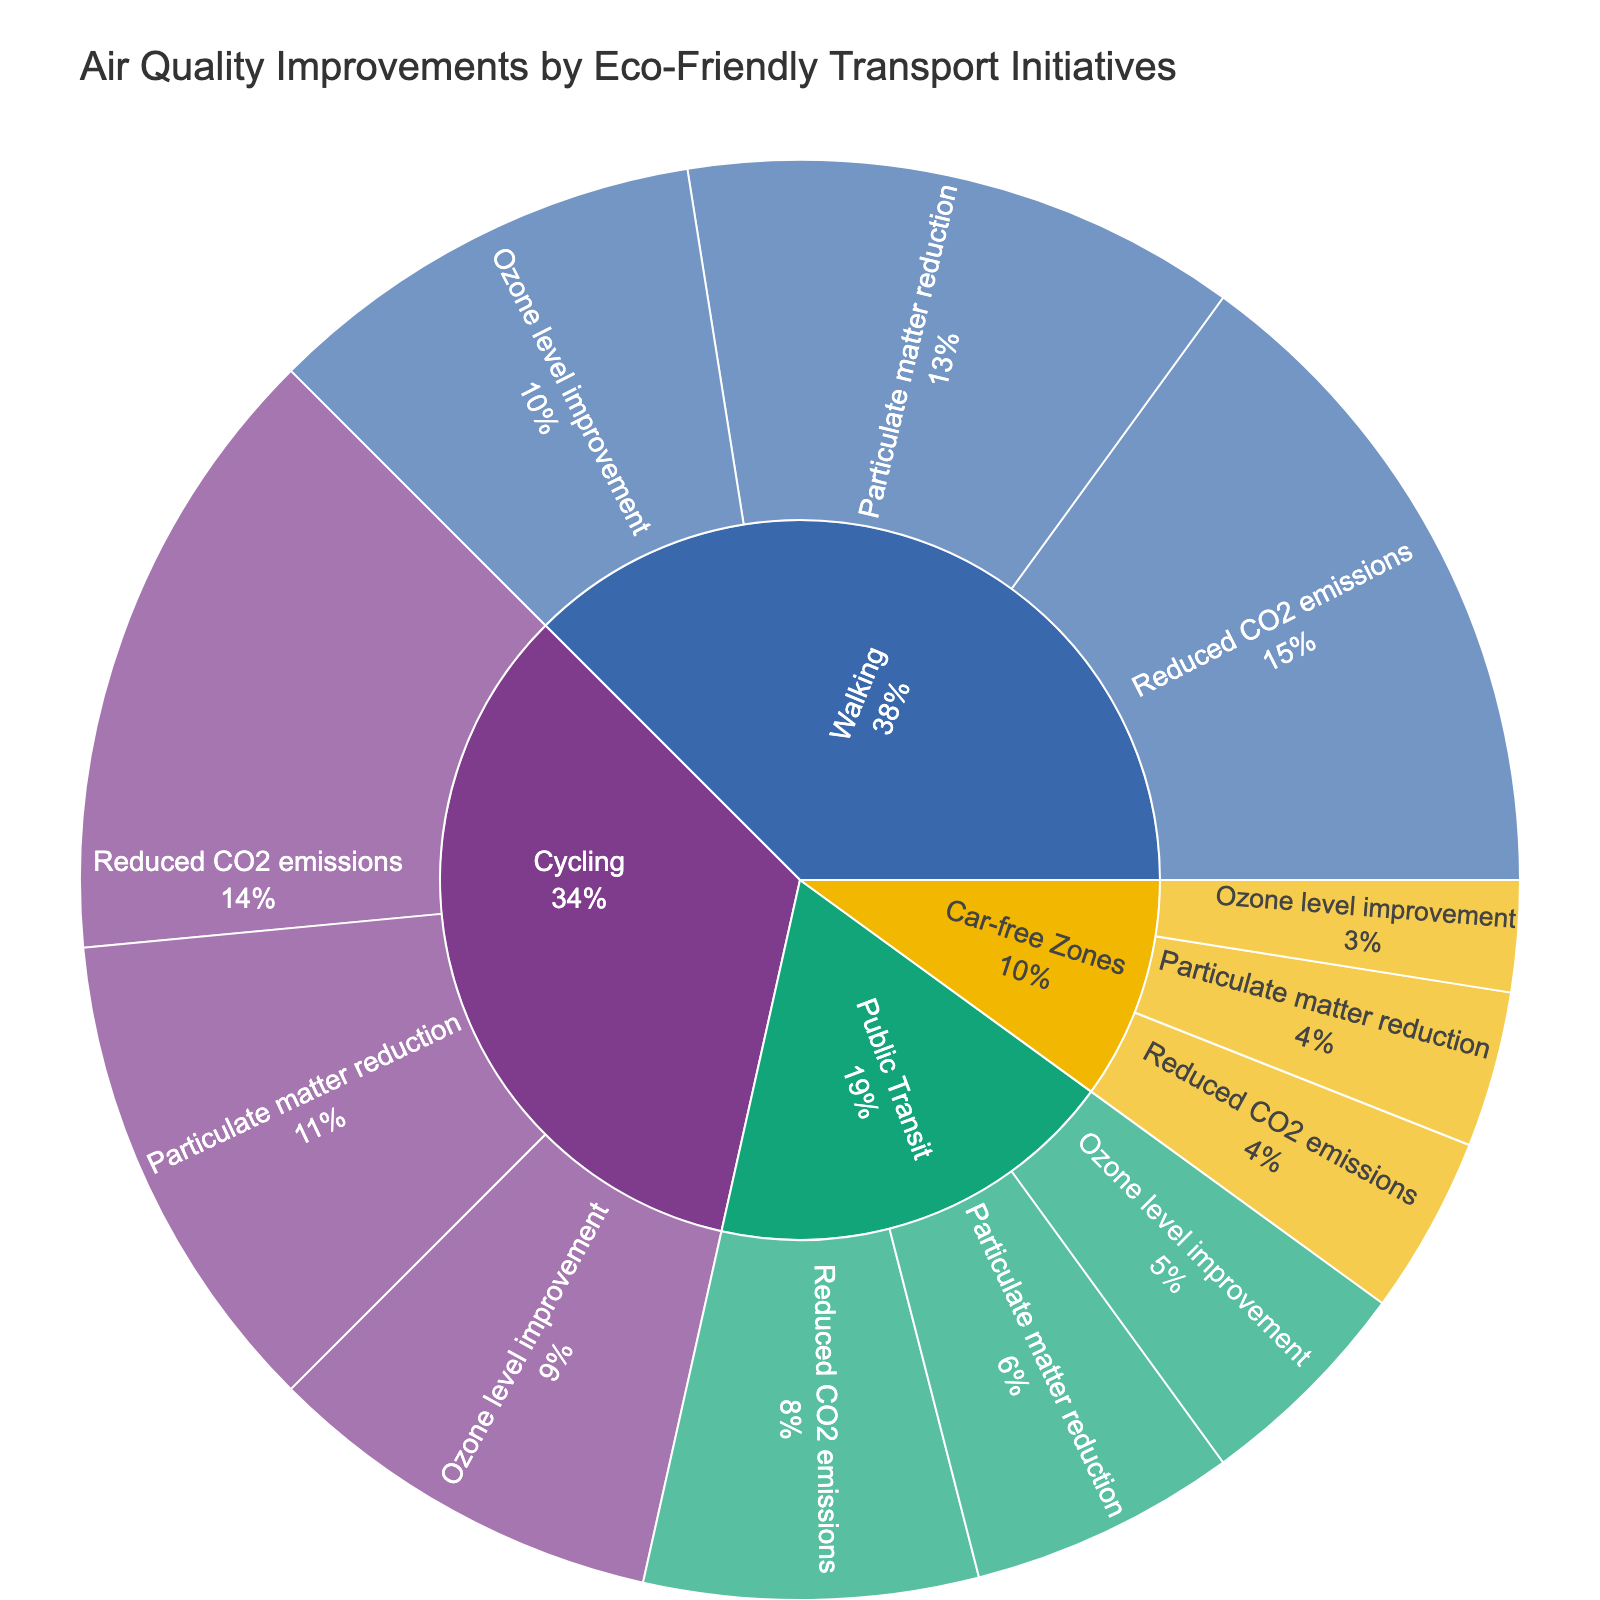What is the title of the figure? The title of the figure is displayed at the top, giving a summary of what the plot represents.
Answer: Air Quality Improvements by Eco-Friendly Transport Initiatives Which category contributes the most to reduced CO2 emissions? Look for the primary circle segments representing each category and check their subcategories for reduced CO2 emissions and compare their percentages.
Answer: Walking How many subcategories are shown under the "Cycling" category? Count all the segments immediate under the "Cycling" category in the sunburst plot.
Answer: 3 What is the total improvement percentage attributed to "Public Transit"? Add up the percentages indicated for each subcategory under "Public Transit" in the sunburst plot.
Answer: 15% Which initiative has the smallest contribution to "Particulate matter reduction"? Identify the segments listed under "Particulate matter reduction" and find the one with the lowest value or percentage.
Answer: Car-free Zones Compare the percentage contributions to "Ozone level improvement" between "Walking" and "Cycling". Check the percentage values for the "Ozone level improvement" subcategory under both the "Walking" and "Cycling" categories and compare them.
Answer: Walking > Cycling What is the combined contribution percentage of "Cycling" to reduced CO2 emissions, particulate matter reduction, and ozone level improvement? Sum the individual contributions of the three subcategories under "Cycling".
Answer: 68% Which category shows the highest percentage for particulate matter reduction? Find and compare the percentages for particulate matter under each main category.
Answer: Walking What percentage of the total improvement is attributed to "Car-free Zones"? Sum up the values of all subcategories under "Car-free Zones" and calculate the percentage out of the total improvements.
Answer: 20% Is the contribution of "Public Transit" to "Ozone level improvement" higher or lower than its contribution to "Particulate matter reduction"? Compare the segments for "Public Transit" under both "Ozone level improvement" and "Particulate matter reduction".
Answer: Lower 